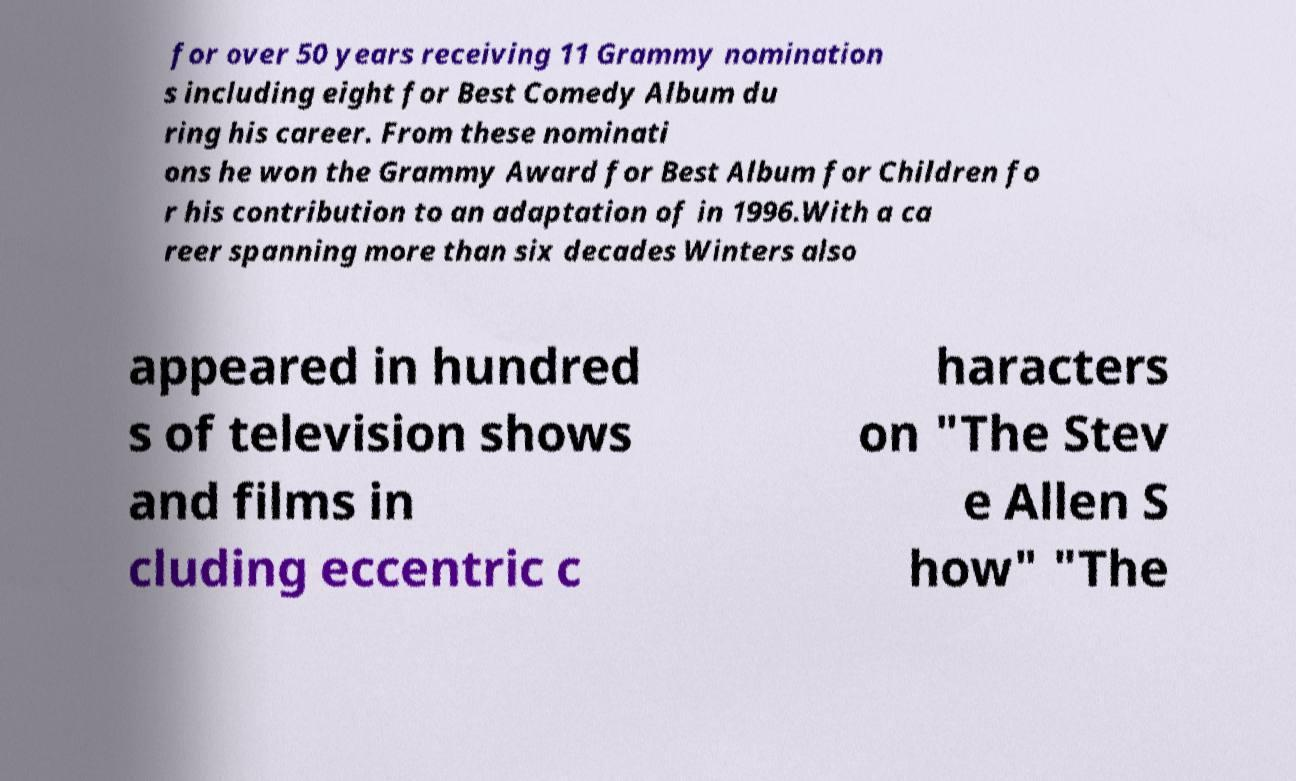There's text embedded in this image that I need extracted. Can you transcribe it verbatim? for over 50 years receiving 11 Grammy nomination s including eight for Best Comedy Album du ring his career. From these nominati ons he won the Grammy Award for Best Album for Children fo r his contribution to an adaptation of in 1996.With a ca reer spanning more than six decades Winters also appeared in hundred s of television shows and films in cluding eccentric c haracters on "The Stev e Allen S how" "The 